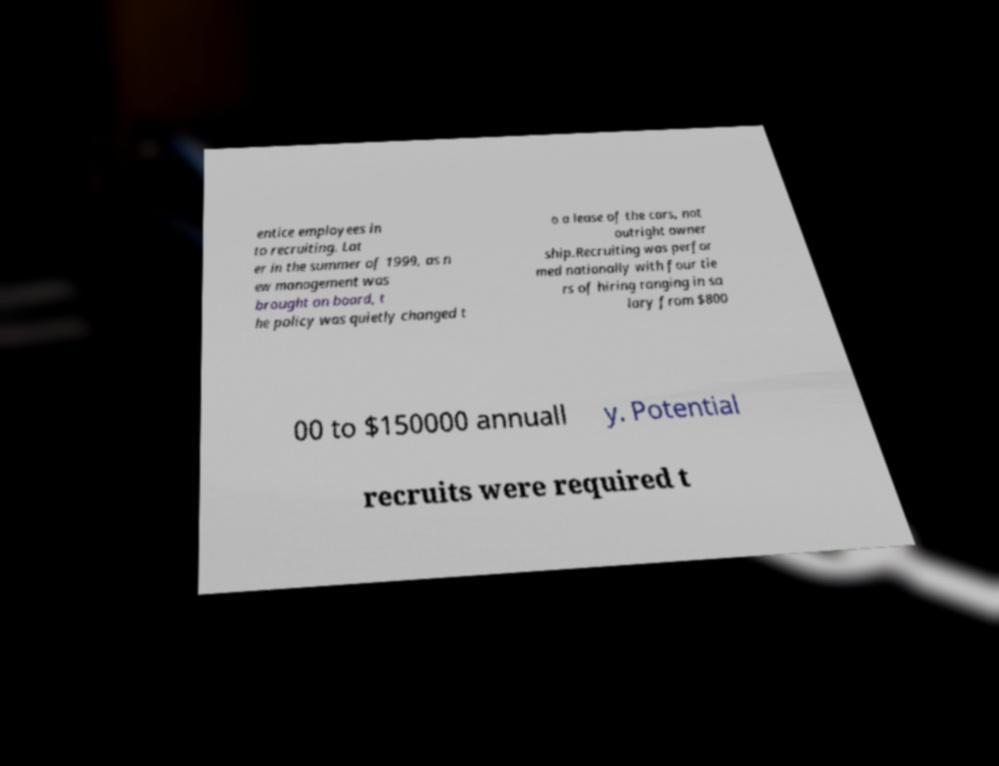Can you accurately transcribe the text from the provided image for me? entice employees in to recruiting. Lat er in the summer of 1999, as n ew management was brought on board, t he policy was quietly changed t o a lease of the cars, not outright owner ship.Recruiting was perfor med nationally with four tie rs of hiring ranging in sa lary from $800 00 to $150000 annuall y. Potential recruits were required t 